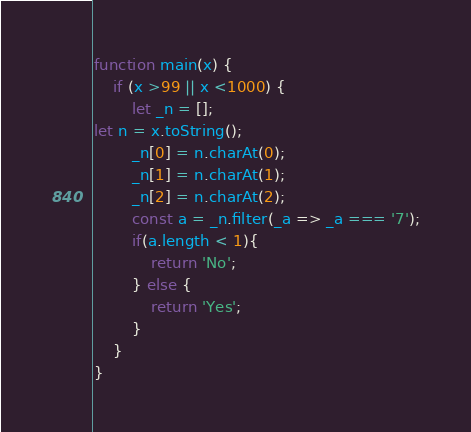<code> <loc_0><loc_0><loc_500><loc_500><_JavaScript_>function main(x) {
    if (x >99 || x <1000) {
        let _n = [];
let n = x.toString();
        _n[0] = n.charAt(0);
        _n[1] = n.charAt(1);
        _n[2] = n.charAt(2);
        const a = _n.filter(_a => _a === '7');
        if(a.length < 1){
            return 'No';
        } else {
            return 'Yes';
        }
    }
}</code> 